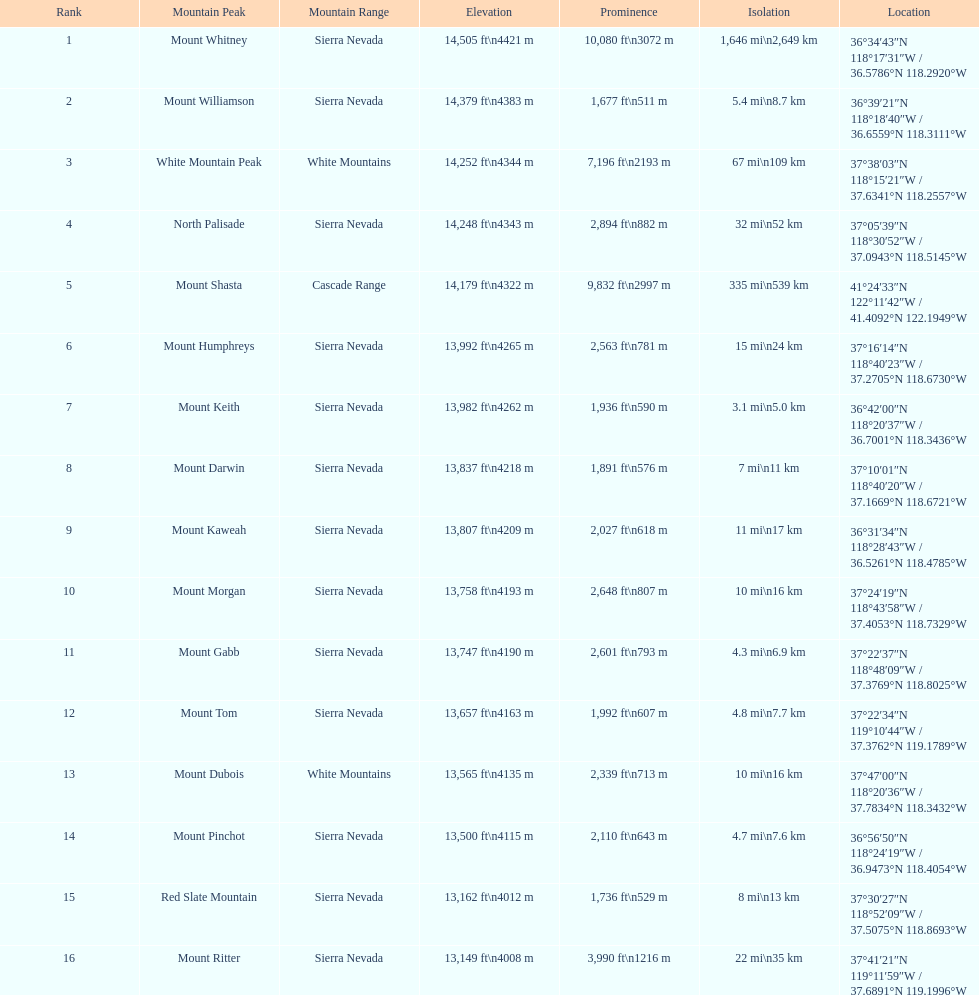Help me parse the entirety of this table. {'header': ['Rank', 'Mountain Peak', 'Mountain Range', 'Elevation', 'Prominence', 'Isolation', 'Location'], 'rows': [['1', 'Mount Whitney', 'Sierra Nevada', '14,505\xa0ft\\n4421\xa0m', '10,080\xa0ft\\n3072\xa0m', '1,646\xa0mi\\n2,649\xa0km', '36°34′43″N 118°17′31″W\ufeff / \ufeff36.5786°N 118.2920°W'], ['2', 'Mount Williamson', 'Sierra Nevada', '14,379\xa0ft\\n4383\xa0m', '1,677\xa0ft\\n511\xa0m', '5.4\xa0mi\\n8.7\xa0km', '36°39′21″N 118°18′40″W\ufeff / \ufeff36.6559°N 118.3111°W'], ['3', 'White Mountain Peak', 'White Mountains', '14,252\xa0ft\\n4344\xa0m', '7,196\xa0ft\\n2193\xa0m', '67\xa0mi\\n109\xa0km', '37°38′03″N 118°15′21″W\ufeff / \ufeff37.6341°N 118.2557°W'], ['4', 'North Palisade', 'Sierra Nevada', '14,248\xa0ft\\n4343\xa0m', '2,894\xa0ft\\n882\xa0m', '32\xa0mi\\n52\xa0km', '37°05′39″N 118°30′52″W\ufeff / \ufeff37.0943°N 118.5145°W'], ['5', 'Mount Shasta', 'Cascade Range', '14,179\xa0ft\\n4322\xa0m', '9,832\xa0ft\\n2997\xa0m', '335\xa0mi\\n539\xa0km', '41°24′33″N 122°11′42″W\ufeff / \ufeff41.4092°N 122.1949°W'], ['6', 'Mount Humphreys', 'Sierra Nevada', '13,992\xa0ft\\n4265\xa0m', '2,563\xa0ft\\n781\xa0m', '15\xa0mi\\n24\xa0km', '37°16′14″N 118°40′23″W\ufeff / \ufeff37.2705°N 118.6730°W'], ['7', 'Mount Keith', 'Sierra Nevada', '13,982\xa0ft\\n4262\xa0m', '1,936\xa0ft\\n590\xa0m', '3.1\xa0mi\\n5.0\xa0km', '36°42′00″N 118°20′37″W\ufeff / \ufeff36.7001°N 118.3436°W'], ['8', 'Mount Darwin', 'Sierra Nevada', '13,837\xa0ft\\n4218\xa0m', '1,891\xa0ft\\n576\xa0m', '7\xa0mi\\n11\xa0km', '37°10′01″N 118°40′20″W\ufeff / \ufeff37.1669°N 118.6721°W'], ['9', 'Mount Kaweah', 'Sierra Nevada', '13,807\xa0ft\\n4209\xa0m', '2,027\xa0ft\\n618\xa0m', '11\xa0mi\\n17\xa0km', '36°31′34″N 118°28′43″W\ufeff / \ufeff36.5261°N 118.4785°W'], ['10', 'Mount Morgan', 'Sierra Nevada', '13,758\xa0ft\\n4193\xa0m', '2,648\xa0ft\\n807\xa0m', '10\xa0mi\\n16\xa0km', '37°24′19″N 118°43′58″W\ufeff / \ufeff37.4053°N 118.7329°W'], ['11', 'Mount Gabb', 'Sierra Nevada', '13,747\xa0ft\\n4190\xa0m', '2,601\xa0ft\\n793\xa0m', '4.3\xa0mi\\n6.9\xa0km', '37°22′37″N 118°48′09″W\ufeff / \ufeff37.3769°N 118.8025°W'], ['12', 'Mount Tom', 'Sierra Nevada', '13,657\xa0ft\\n4163\xa0m', '1,992\xa0ft\\n607\xa0m', '4.8\xa0mi\\n7.7\xa0km', '37°22′34″N 119°10′44″W\ufeff / \ufeff37.3762°N 119.1789°W'], ['13', 'Mount Dubois', 'White Mountains', '13,565\xa0ft\\n4135\xa0m', '2,339\xa0ft\\n713\xa0m', '10\xa0mi\\n16\xa0km', '37°47′00″N 118°20′36″W\ufeff / \ufeff37.7834°N 118.3432°W'], ['14', 'Mount Pinchot', 'Sierra Nevada', '13,500\xa0ft\\n4115\xa0m', '2,110\xa0ft\\n643\xa0m', '4.7\xa0mi\\n7.6\xa0km', '36°56′50″N 118°24′19″W\ufeff / \ufeff36.9473°N 118.4054°W'], ['15', 'Red Slate Mountain', 'Sierra Nevada', '13,162\xa0ft\\n4012\xa0m', '1,736\xa0ft\\n529\xa0m', '8\xa0mi\\n13\xa0km', '37°30′27″N 118°52′09″W\ufeff / \ufeff37.5075°N 118.8693°W'], ['16', 'Mount Ritter', 'Sierra Nevada', '13,149\xa0ft\\n4008\xa0m', '3,990\xa0ft\\n1216\xa0m', '22\xa0mi\\n35\xa0km', '37°41′21″N 119°11′59″W\ufeff / \ufeff37.6891°N 119.1996°W']]} Which mountain summit has the lowest isolation? Mount Keith. 